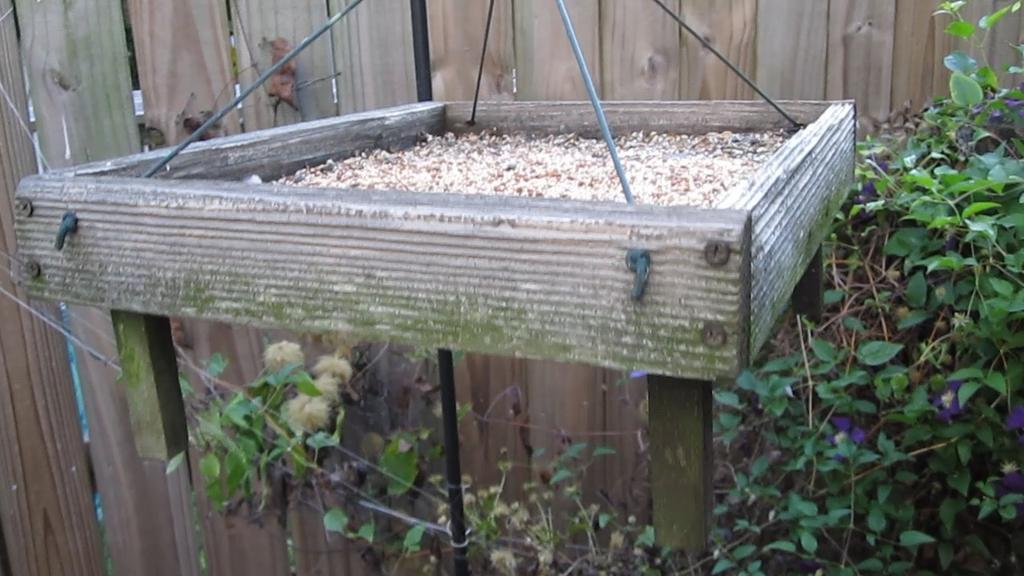What type of plant can be seen in the bottom right corner of the image? There are leaves and stems of a plant in the bottom right corner of the image. What is the main subject in the middle of the image? There is an object in the middle of the image. What type of wall is visible in the background of the image? There is a wooden wall in the background of the image. What arithmetic problem is being solved on the wooden wall in the image? There is no arithmetic problem visible on the wooden wall in the image. What country is depicted in the scene shown in the image? The image does not depict a scene from a specific country; it only contains a plant, an object, and a wooden wall. 